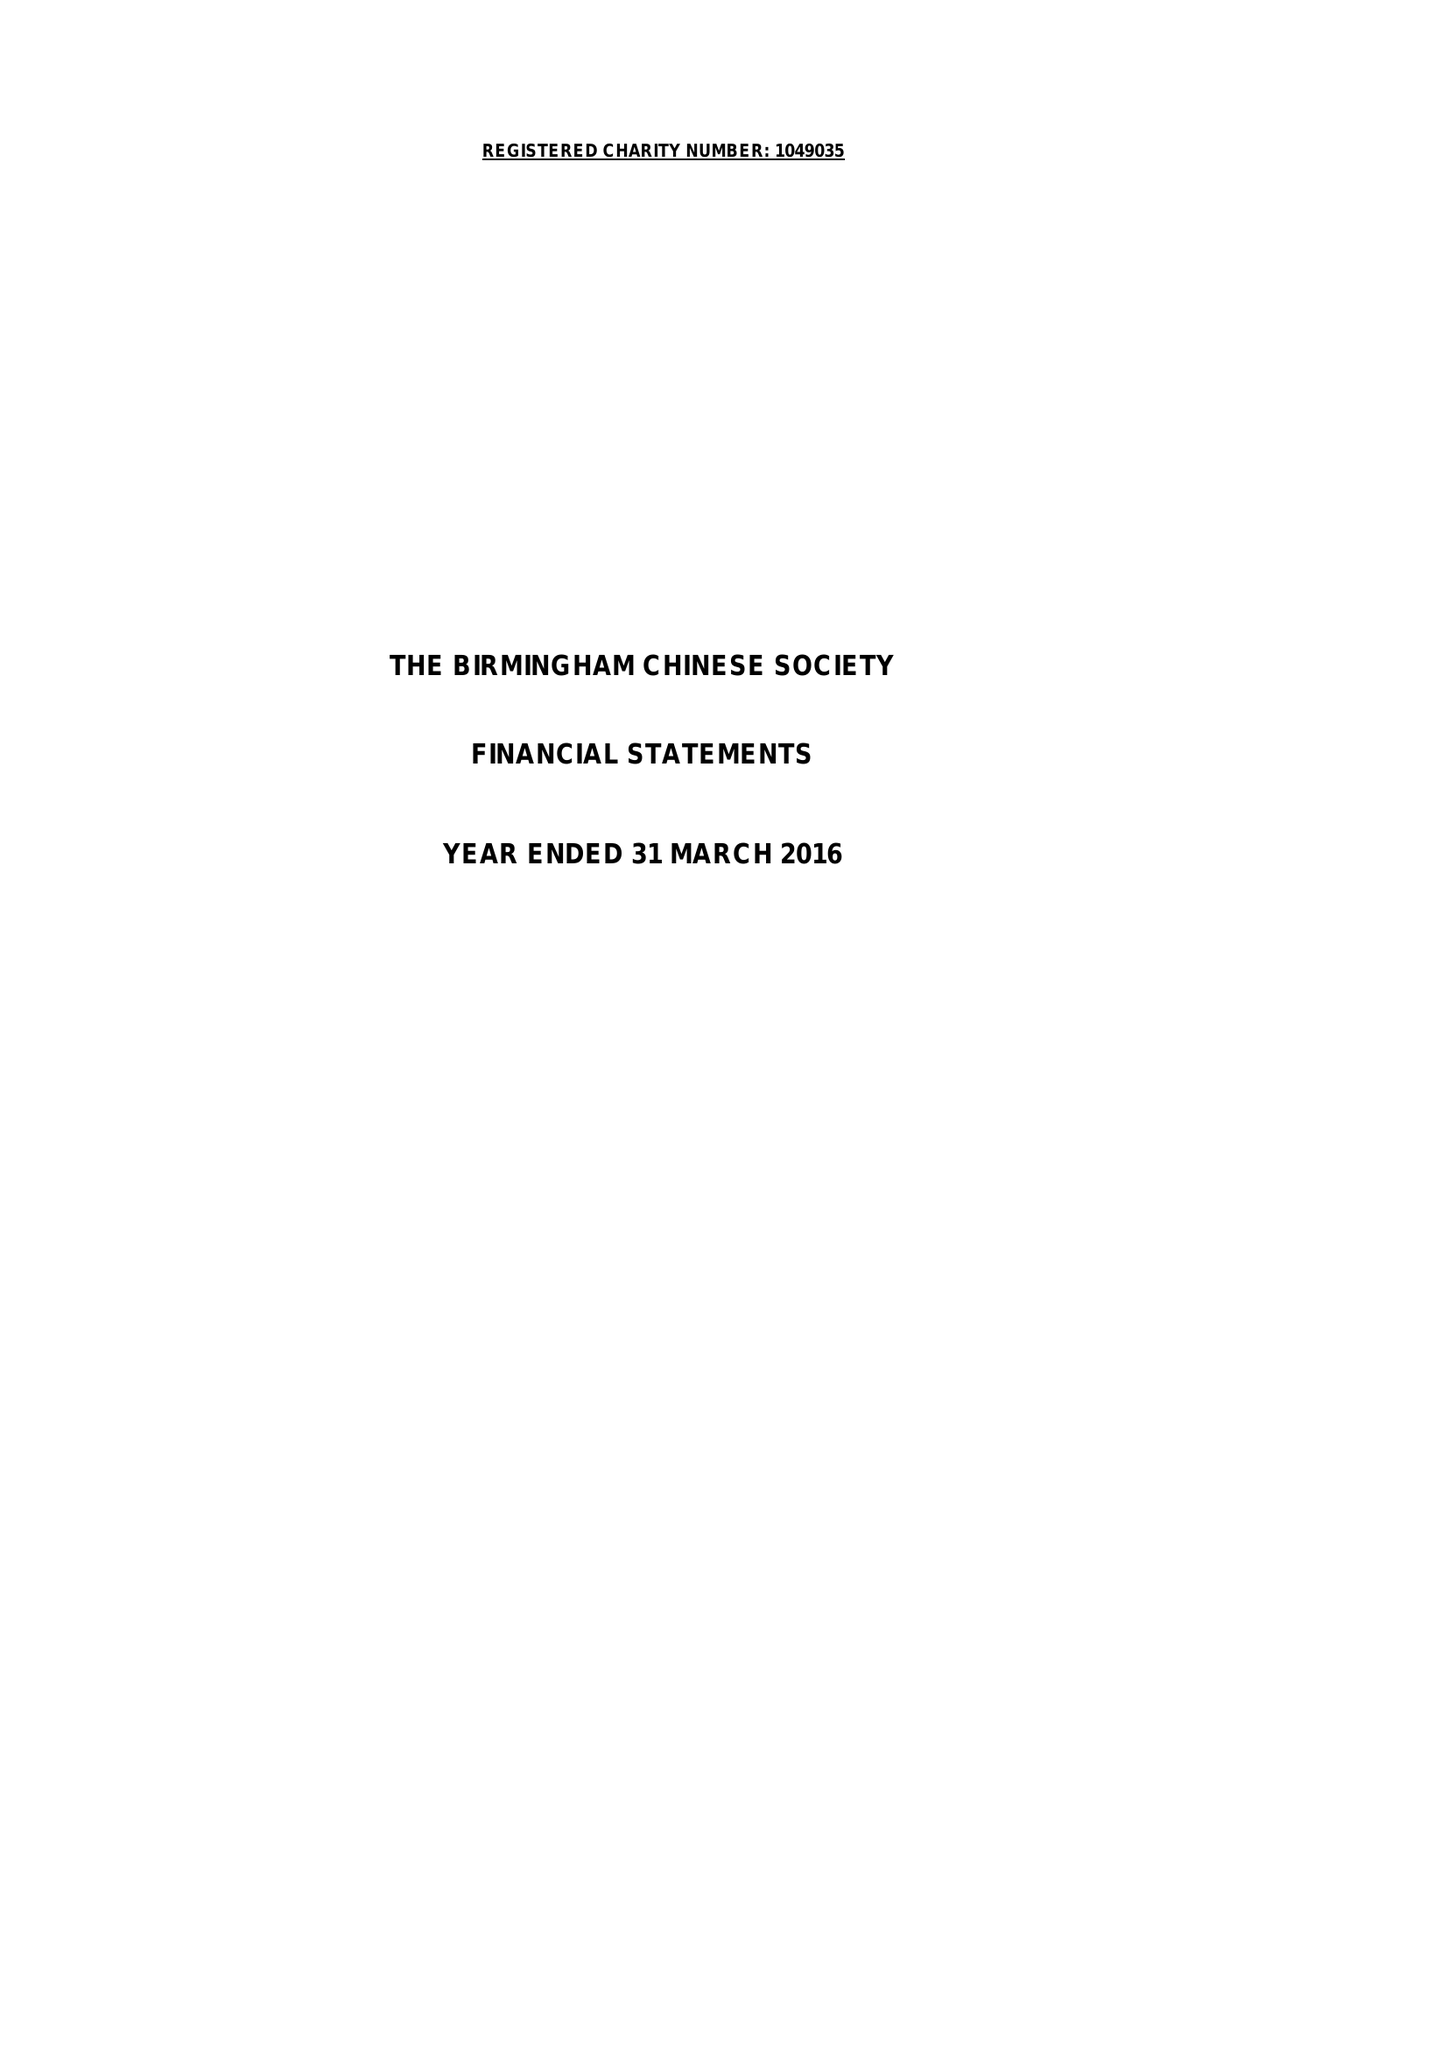What is the value for the spending_annually_in_british_pounds?
Answer the question using a single word or phrase. 67014.00 